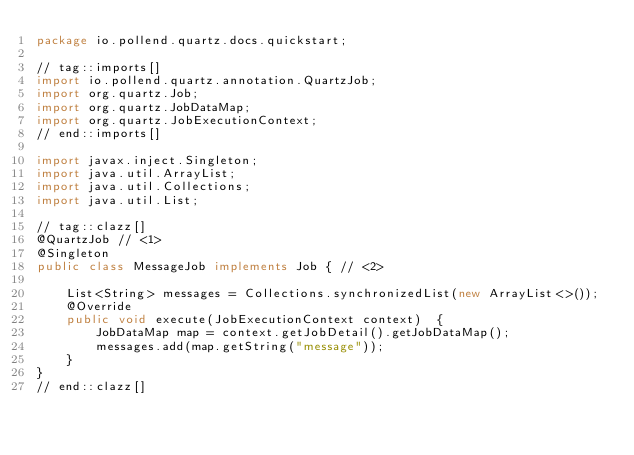Convert code to text. <code><loc_0><loc_0><loc_500><loc_500><_Java_>package io.pollend.quartz.docs.quickstart;

// tag::imports[]
import io.pollend.quartz.annotation.QuartzJob;
import org.quartz.Job;
import org.quartz.JobDataMap;
import org.quartz.JobExecutionContext;
// end::imports[]

import javax.inject.Singleton;
import java.util.ArrayList;
import java.util.Collections;
import java.util.List;

// tag::clazz[]
@QuartzJob // <1>
@Singleton
public class MessageJob implements Job { // <2>

    List<String> messages = Collections.synchronizedList(new ArrayList<>());
    @Override
    public void execute(JobExecutionContext context)  {
        JobDataMap map = context.getJobDetail().getJobDataMap();
        messages.add(map.getString("message"));
    }
}
// end::clazz[]
</code> 